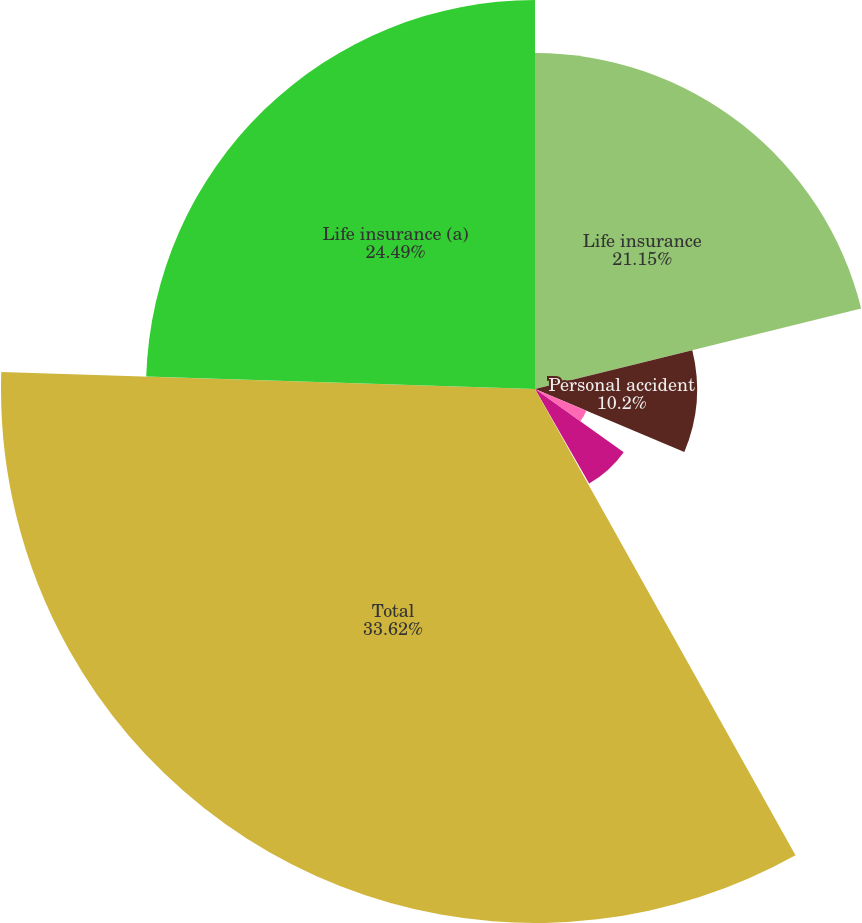Convert chart. <chart><loc_0><loc_0><loc_500><loc_500><pie_chart><fcel>Life insurance<fcel>Personal accident<fcel>Group products<fcel>Individual fixed annuities<fcel>Individual variable annuities<fcel>Total<fcel>Life insurance (a)<nl><fcel>21.15%<fcel>10.2%<fcel>3.51%<fcel>6.86%<fcel>0.17%<fcel>33.62%<fcel>24.49%<nl></chart> 